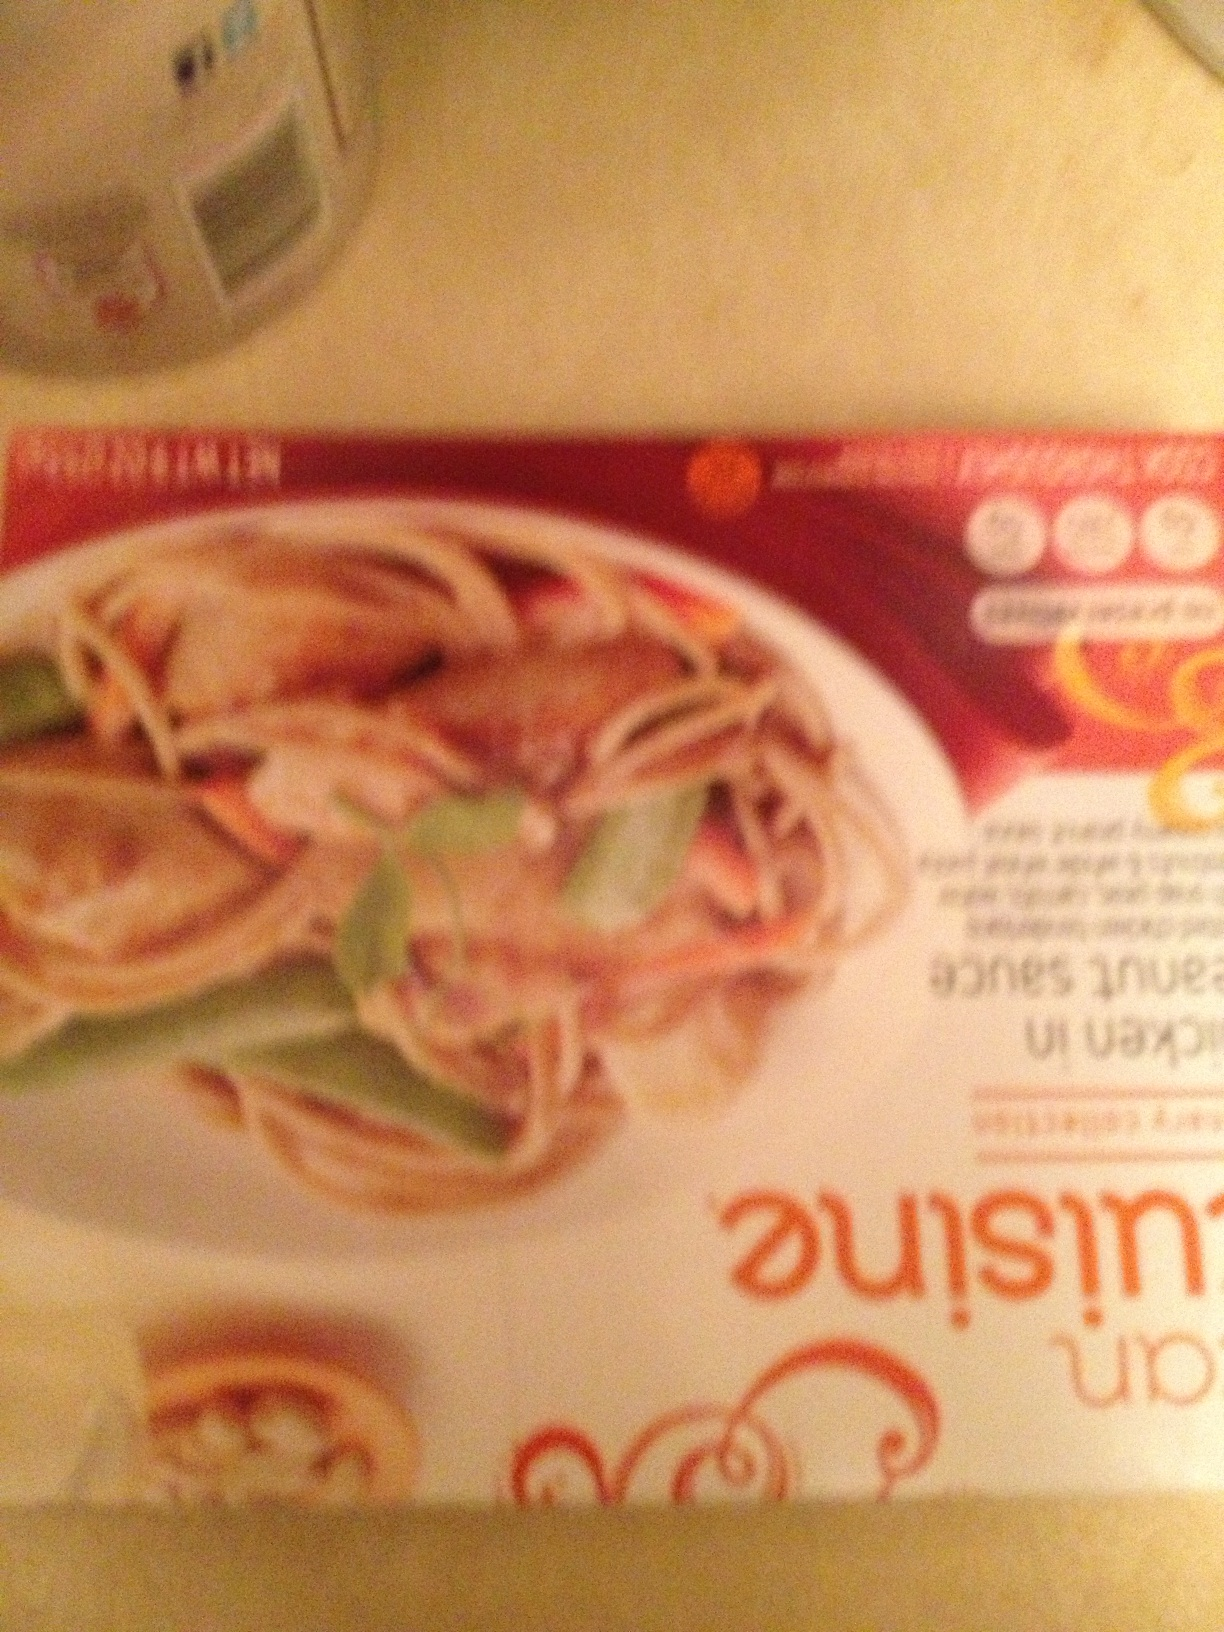Can you tell anything about the nutritional content mentioned on the package? The text regarding nutritional content is too blurred to read clearly from the image. However, meals like this often contain nutritional information about calorie count, ingredients list, allergens, and serving suggestions on their packaging. 